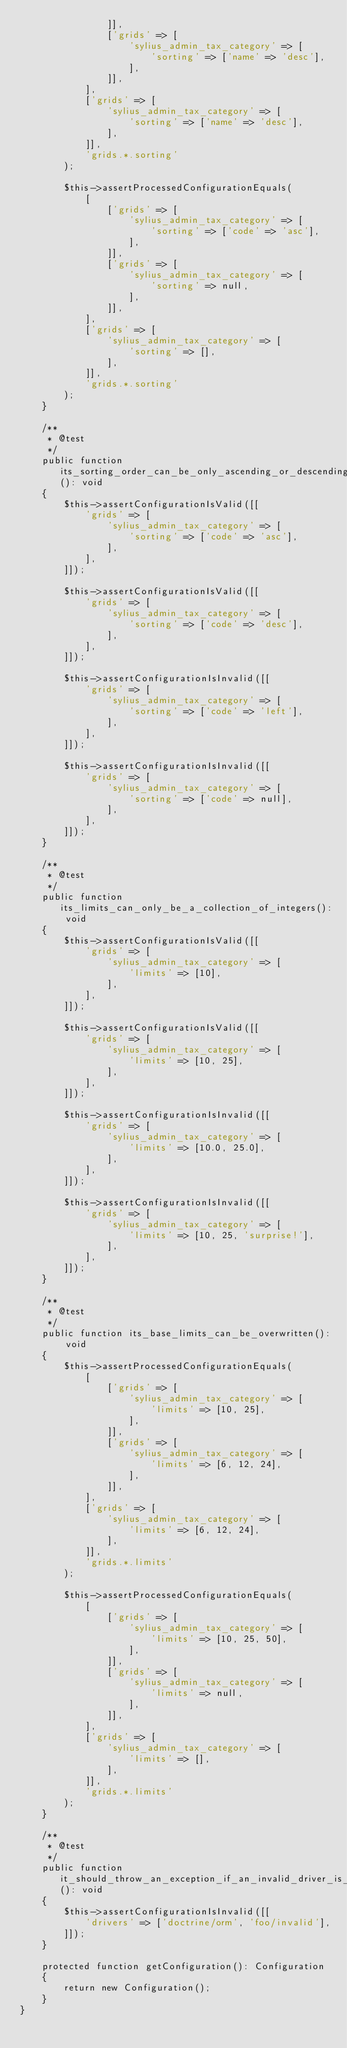<code> <loc_0><loc_0><loc_500><loc_500><_PHP_>                ]],
                ['grids' => [
                    'sylius_admin_tax_category' => [
                        'sorting' => ['name' => 'desc'],
                    ],
                ]],
            ],
            ['grids' => [
                'sylius_admin_tax_category' => [
                    'sorting' => ['name' => 'desc'],
                ],
            ]],
            'grids.*.sorting'
        );

        $this->assertProcessedConfigurationEquals(
            [
                ['grids' => [
                    'sylius_admin_tax_category' => [
                        'sorting' => ['code' => 'asc'],
                    ],
                ]],
                ['grids' => [
                    'sylius_admin_tax_category' => [
                        'sorting' => null,
                    ],
                ]],
            ],
            ['grids' => [
                'sylius_admin_tax_category' => [
                    'sorting' => [],
                ],
            ]],
            'grids.*.sorting'
        );
    }

    /**
     * @test
     */
    public function its_sorting_order_can_be_only_ascending_or_descending(): void
    {
        $this->assertConfigurationIsValid([[
            'grids' => [
                'sylius_admin_tax_category' => [
                    'sorting' => ['code' => 'asc'],
                ],
            ],
        ]]);

        $this->assertConfigurationIsValid([[
            'grids' => [
                'sylius_admin_tax_category' => [
                    'sorting' => ['code' => 'desc'],
                ],
            ],
        ]]);

        $this->assertConfigurationIsInvalid([[
            'grids' => [
                'sylius_admin_tax_category' => [
                    'sorting' => ['code' => 'left'],
                ],
            ],
        ]]);

        $this->assertConfigurationIsInvalid([[
            'grids' => [
                'sylius_admin_tax_category' => [
                    'sorting' => ['code' => null],
                ],
            ],
        ]]);
    }

    /**
     * @test
     */
    public function its_limits_can_only_be_a_collection_of_integers(): void
    {
        $this->assertConfigurationIsValid([[
            'grids' => [
                'sylius_admin_tax_category' => [
                    'limits' => [10],
                ],
            ],
        ]]);

        $this->assertConfigurationIsValid([[
            'grids' => [
                'sylius_admin_tax_category' => [
                    'limits' => [10, 25],
                ],
            ],
        ]]);

        $this->assertConfigurationIsInvalid([[
            'grids' => [
                'sylius_admin_tax_category' => [
                    'limits' => [10.0, 25.0],
                ],
            ],
        ]]);

        $this->assertConfigurationIsInvalid([[
            'grids' => [
                'sylius_admin_tax_category' => [
                    'limits' => [10, 25, 'surprise!'],
                ],
            ],
        ]]);
    }

    /**
     * @test
     */
    public function its_base_limits_can_be_overwritten(): void
    {
        $this->assertProcessedConfigurationEquals(
            [
                ['grids' => [
                    'sylius_admin_tax_category' => [
                        'limits' => [10, 25],
                    ],
                ]],
                ['grids' => [
                    'sylius_admin_tax_category' => [
                        'limits' => [6, 12, 24],
                    ],
                ]],
            ],
            ['grids' => [
                'sylius_admin_tax_category' => [
                    'limits' => [6, 12, 24],
                ],
            ]],
            'grids.*.limits'
        );

        $this->assertProcessedConfigurationEquals(
            [
                ['grids' => [
                    'sylius_admin_tax_category' => [
                        'limits' => [10, 25, 50],
                    ],
                ]],
                ['grids' => [
                    'sylius_admin_tax_category' => [
                        'limits' => null,
                    ],
                ]],
            ],
            ['grids' => [
                'sylius_admin_tax_category' => [
                    'limits' => [],
                ],
            ]],
            'grids.*.limits'
        );
    }

    /**
     * @test
     */
    public function it_should_throw_an_exception_if_an_invalid_driver_is_enabled(): void
    {
        $this->assertConfigurationIsInvalid([[
            'drivers' => ['doctrine/orm', 'foo/invalid'],
        ]]);
    }

    protected function getConfiguration(): Configuration
    {
        return new Configuration();
    }
}
</code> 